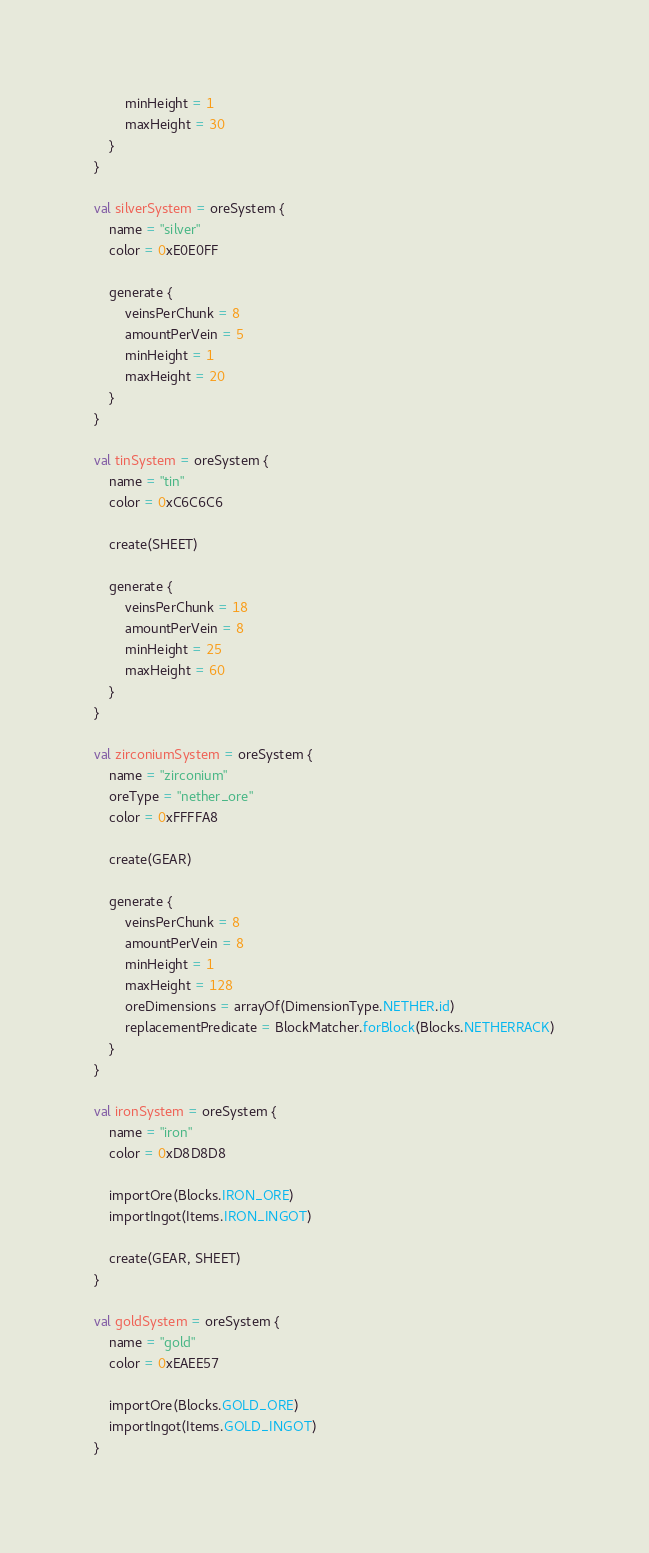Convert code to text. <code><loc_0><loc_0><loc_500><loc_500><_Kotlin_>        minHeight = 1
        maxHeight = 30
    }
}

val silverSystem = oreSystem {
    name = "silver"
    color = 0xE0E0FF

    generate {
        veinsPerChunk = 8
        amountPerVein = 5
        minHeight = 1
        maxHeight = 20
    }
}

val tinSystem = oreSystem {
    name = "tin"
    color = 0xC6C6C6

    create(SHEET)

    generate {
        veinsPerChunk = 18
        amountPerVein = 8
        minHeight = 25
        maxHeight = 60
    }
}

val zirconiumSystem = oreSystem {
    name = "zirconium"
    oreType = "nether_ore"
    color = 0xFFFFA8

    create(GEAR)

    generate {
        veinsPerChunk = 8
        amountPerVein = 8
        minHeight = 1
        maxHeight = 128
        oreDimensions = arrayOf(DimensionType.NETHER.id)
        replacementPredicate = BlockMatcher.forBlock(Blocks.NETHERRACK)
    }
}

val ironSystem = oreSystem {
    name = "iron"
    color = 0xD8D8D8

    importOre(Blocks.IRON_ORE)
    importIngot(Items.IRON_INGOT)

    create(GEAR, SHEET)
}

val goldSystem = oreSystem {
    name = "gold"
    color = 0xEAEE57

    importOre(Blocks.GOLD_ORE)
    importIngot(Items.GOLD_INGOT)
}
</code> 